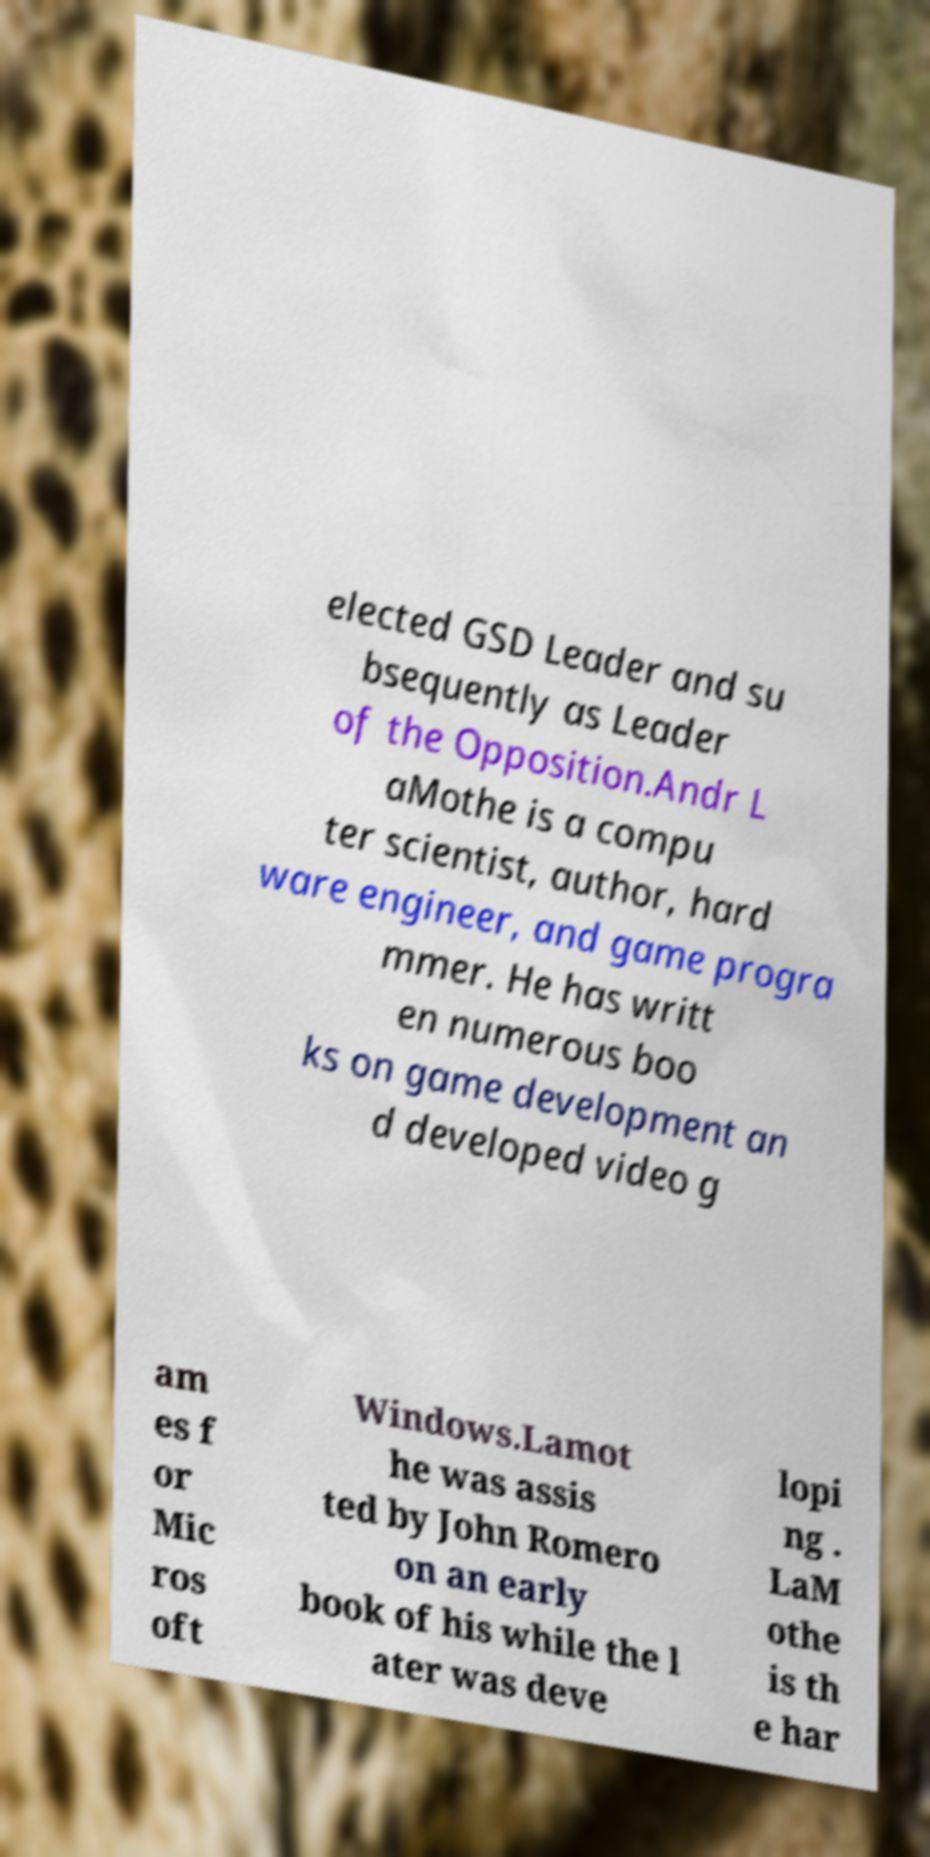For documentation purposes, I need the text within this image transcribed. Could you provide that? elected GSD Leader and su bsequently as Leader of the Opposition.Andr L aMothe is a compu ter scientist, author, hard ware engineer, and game progra mmer. He has writt en numerous boo ks on game development an d developed video g am es f or Mic ros oft Windows.Lamot he was assis ted by John Romero on an early book of his while the l ater was deve lopi ng . LaM othe is th e har 